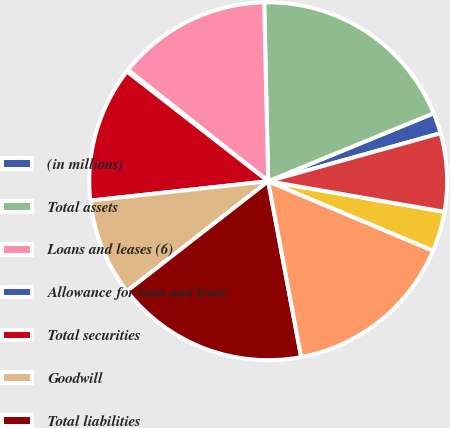<chart> <loc_0><loc_0><loc_500><loc_500><pie_chart><fcel>(in millions)<fcel>Total assets<fcel>Loans and leases (6)<fcel>Allowance for loan and lease<fcel>Total securities<fcel>Goodwill<fcel>Total liabilities<fcel>Total deposits (7)<fcel>Federal funds purchased and<fcel>Other short-term borrowed<nl><fcel>1.88%<fcel>19.15%<fcel>13.97%<fcel>0.16%<fcel>12.24%<fcel>8.79%<fcel>17.43%<fcel>15.7%<fcel>3.61%<fcel>7.06%<nl></chart> 